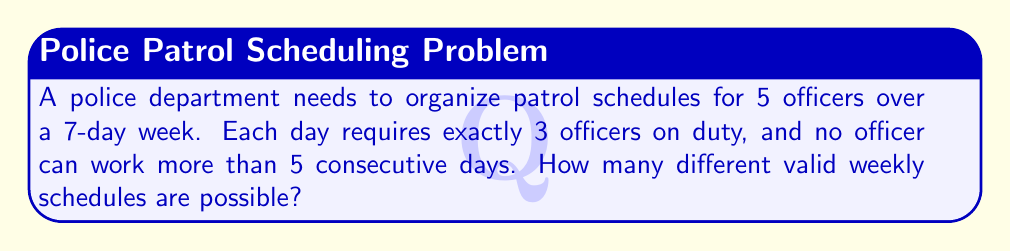Help me with this question. Let's approach this step-by-step:

1) First, we need to determine how many ways we can choose 3 officers from 5 for each day. This is a combination problem, represented as $\binom{5}{3}$.

   $\binom{5}{3} = \frac{5!}{3!(5-3)!} = \frac{5 \cdot 4}{2 \cdot 1} = 10$

2) Now, we have 10 choices for each of the 7 days. Normally, this would give us $10^7$ possibilities.

3) However, we need to account for the constraint that no officer can work more than 5 consecutive days. To do this, we'll use the Inclusion-Exclusion Principle.

4) Let A be the set of all schedules, and B be the set of invalid schedules (where at least one officer works 6 or 7 consecutive days).

5) We want to find |A - B| = |A| - |B|

6) |A| = $10^7$

7) To find |B|, we need to consider schedules where at least one officer works 6 or 7 consecutive days. There are $\binom{5}{1} = 5$ ways to choose this officer.

8) For a 6-day streak, there are 2 possible positions (days 1-6 or 2-7). For a 7-day streak, there's only 1 position.

9) So, for each officer, there are 3 ways they could have an invalid streak.

10) This gives us: |B| = $5 \cdot 3 \cdot 10^1 = 150$

   (We multiply by $10^1$ because for the one day not in the streak, we still have 10 choices)

11) Therefore, the number of valid schedules is:

    |A - B| = $10^7 - 150 = 9,999,850$
Answer: 9,999,850 